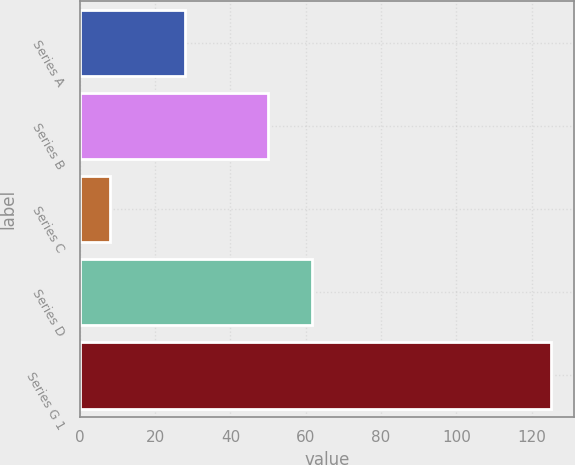<chart> <loc_0><loc_0><loc_500><loc_500><bar_chart><fcel>Series A<fcel>Series B<fcel>Series C<fcel>Series D<fcel>Series G 1<nl><fcel>28<fcel>50<fcel>8<fcel>61.7<fcel>125<nl></chart> 